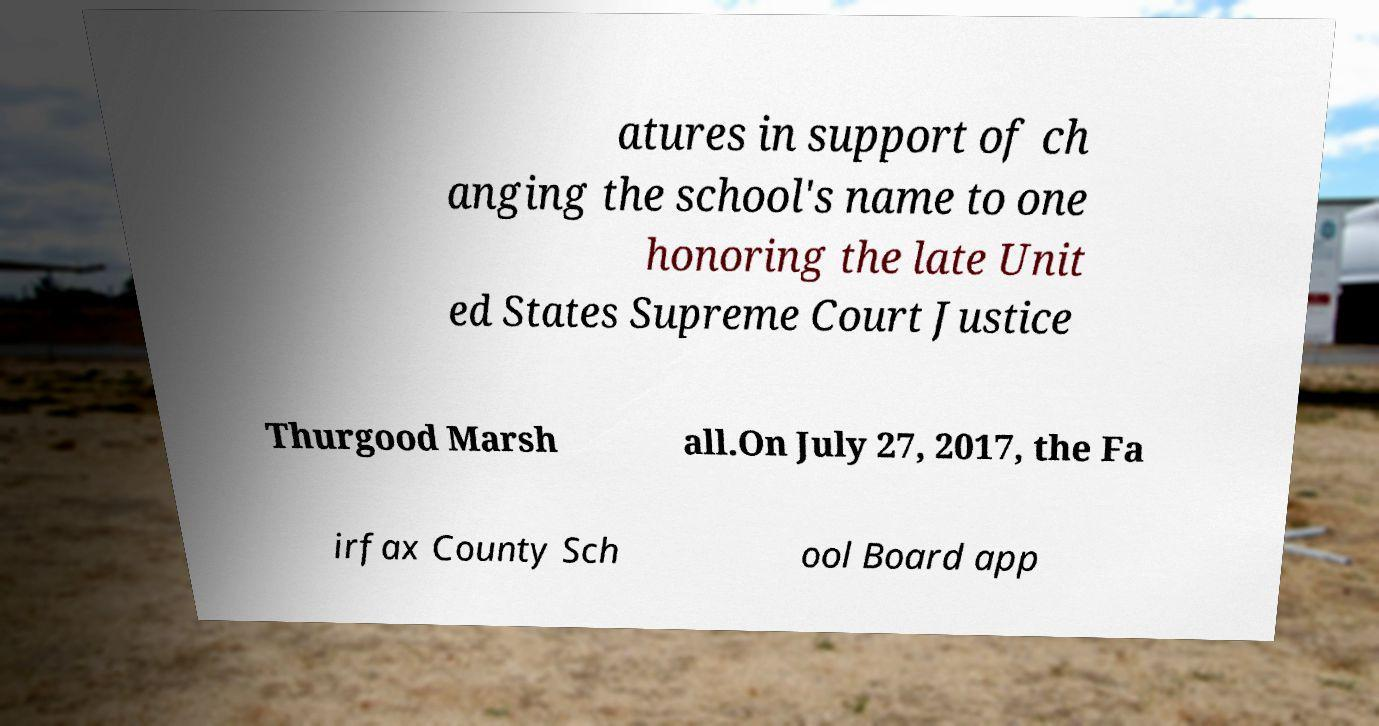Please identify and transcribe the text found in this image. atures in support of ch anging the school's name to one honoring the late Unit ed States Supreme Court Justice Thurgood Marsh all.On July 27, 2017, the Fa irfax County Sch ool Board app 